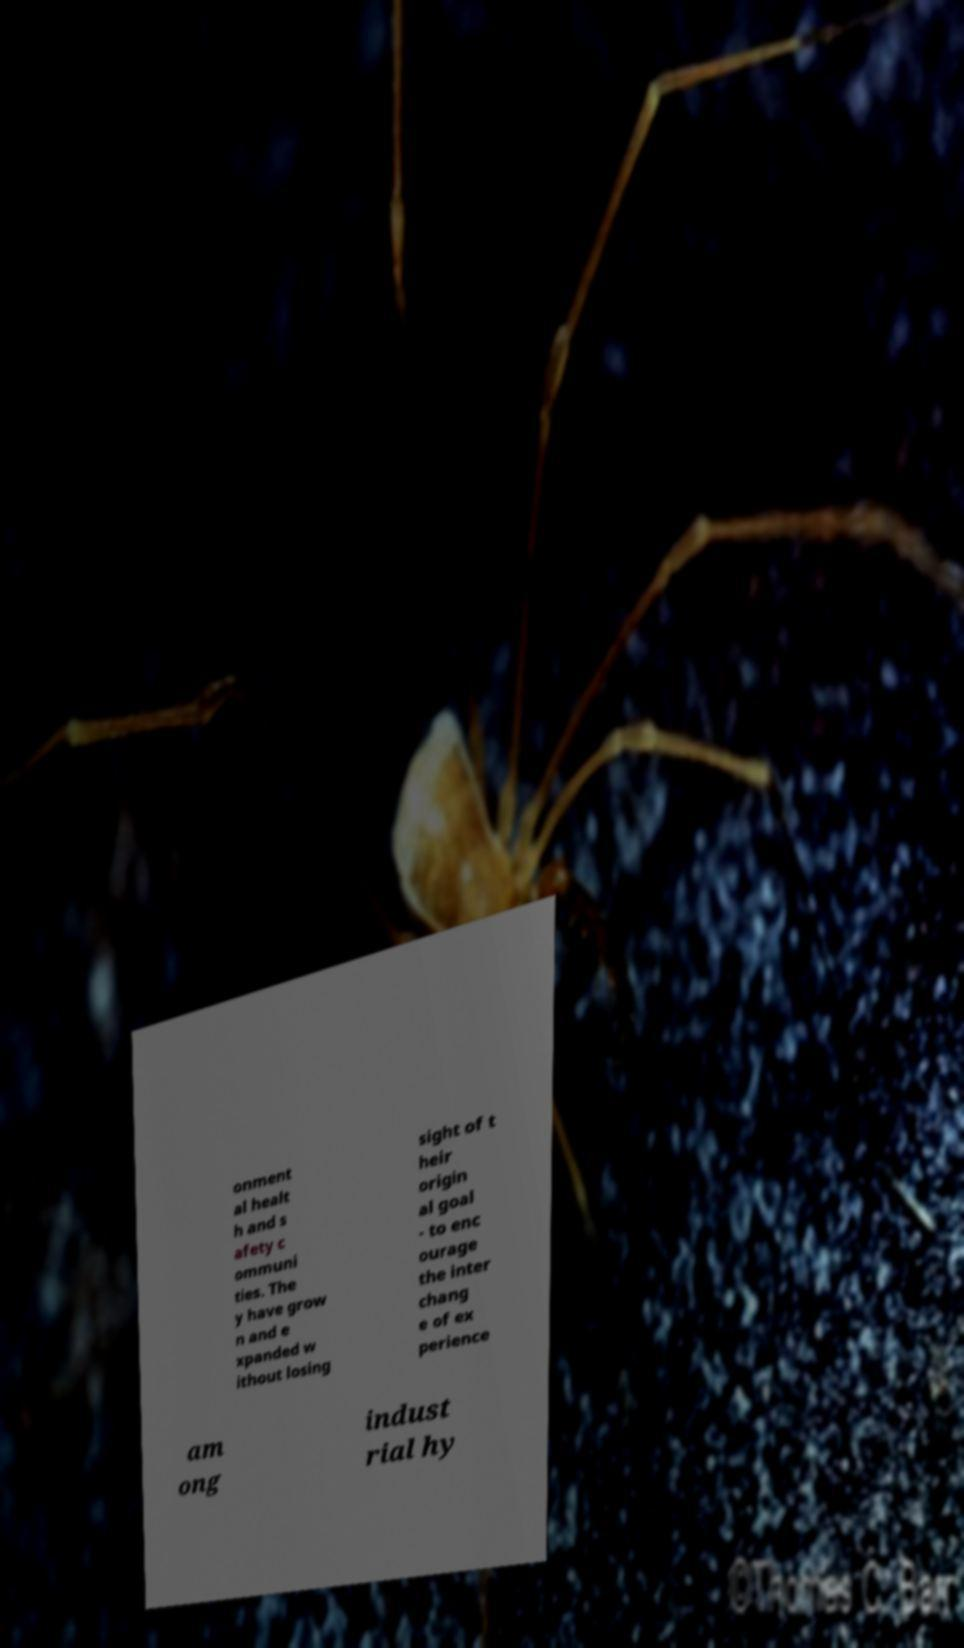Can you accurately transcribe the text from the provided image for me? onment al healt h and s afety c ommuni ties. The y have grow n and e xpanded w ithout losing sight of t heir origin al goal - to enc ourage the inter chang e of ex perience am ong indust rial hy 